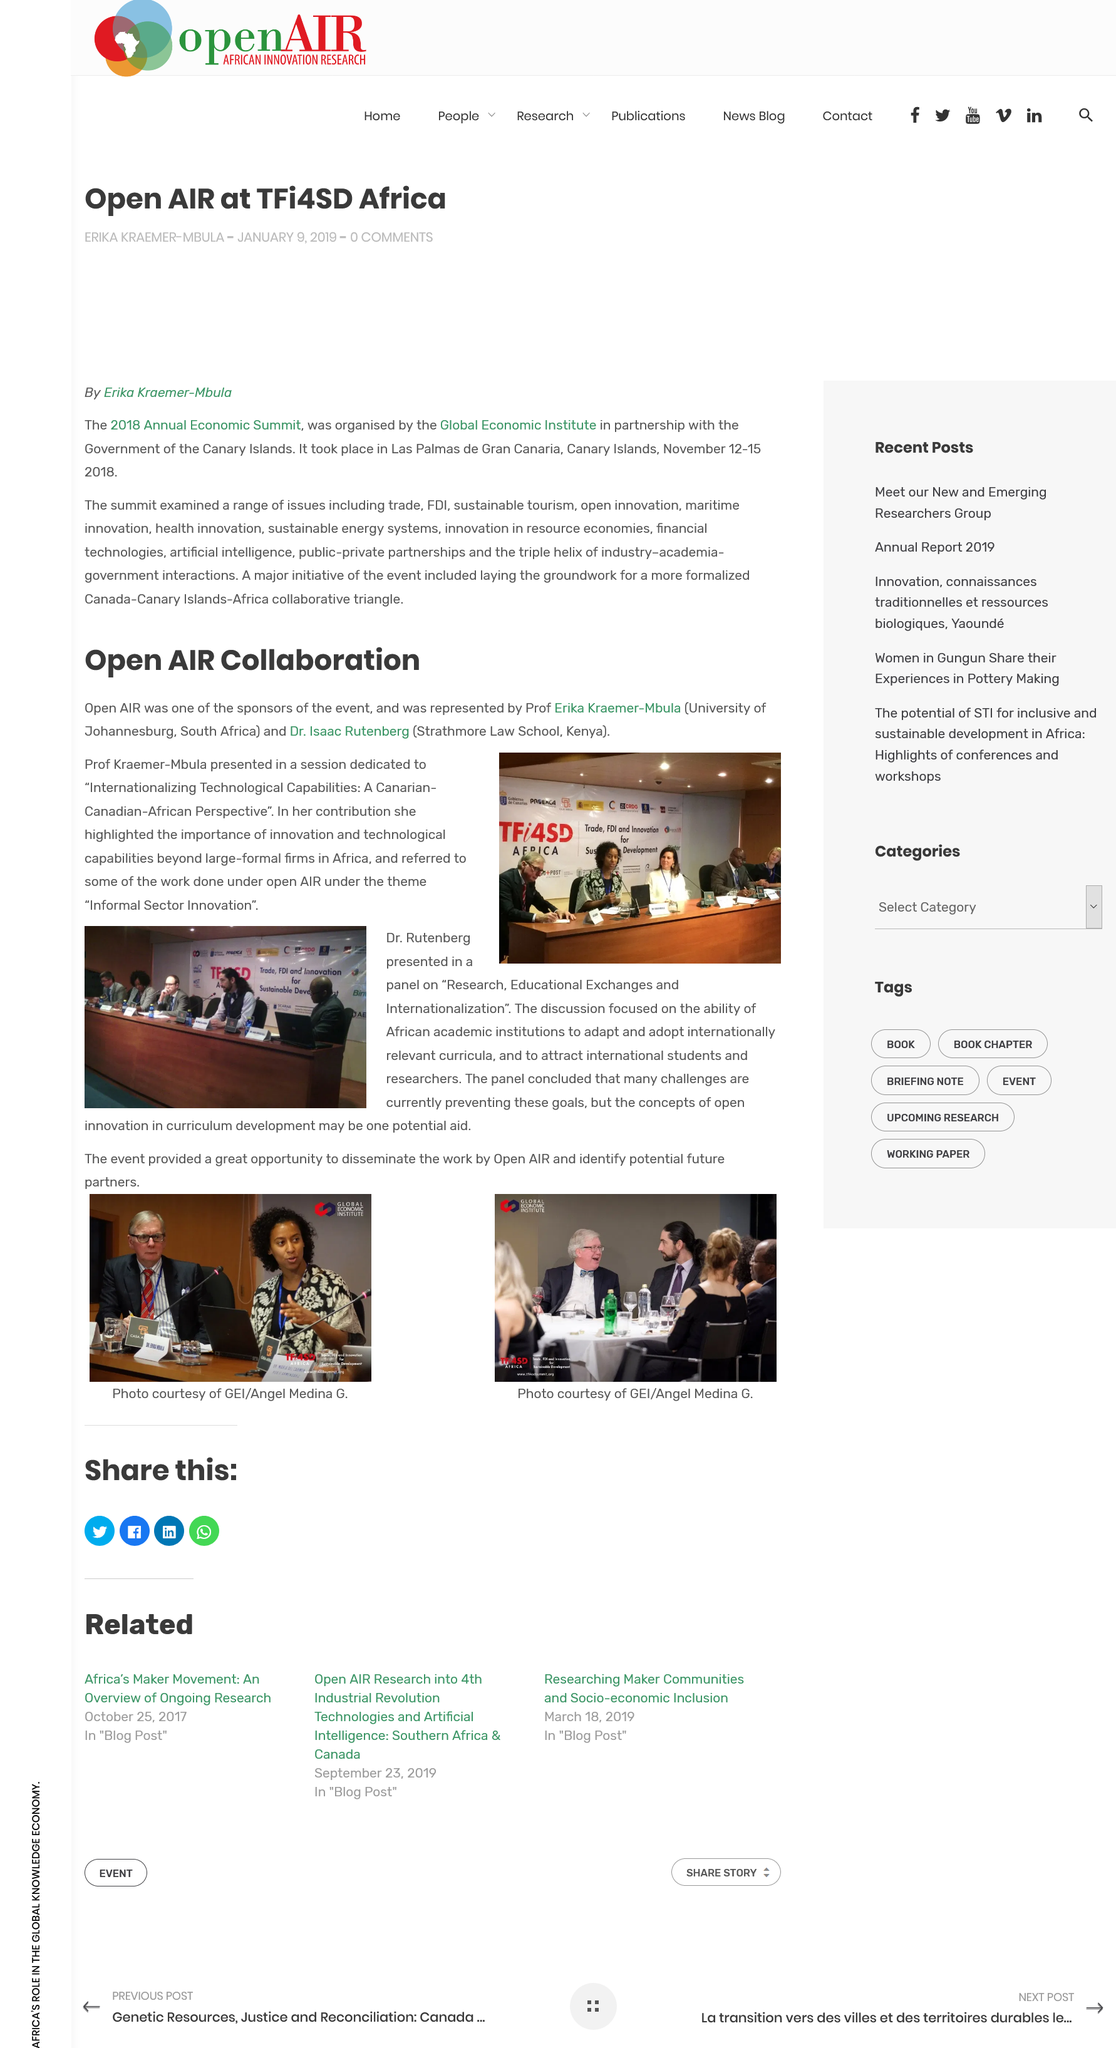Draw attention to some important aspects in this diagram. The 2018 Annual Economic Summit took place in Las Palmas de Gran Canaria, located in the Canary Islands. The Global Economic Institute, in partnership with the Government of the Canary Islands, organized the 2018 Annual Economic Summit. Professor Erika Kraemer-Mbula and Dr. Isaac Rutenberg represented Open Air at the event. Yes, Prof. Kraemer-Mbula highlighted the importance of innovation and technological capabilities beyond large-formal firms in Africa. The 2018 Annual Economic Summit took place from November 12-15, 2018. 